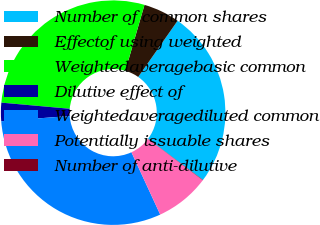<chart> <loc_0><loc_0><loc_500><loc_500><pie_chart><fcel>Number of common shares<fcel>Effectof using weighted<fcel>Weightedaveragebasic common<fcel>Dilutive effect of<fcel>Weightedaveragediluted common<fcel>Potentially issuable shares<fcel>Number of anti-dilutive<nl><fcel>25.5%<fcel>5.23%<fcel>28.08%<fcel>2.64%<fcel>30.67%<fcel>7.82%<fcel>0.06%<nl></chart> 